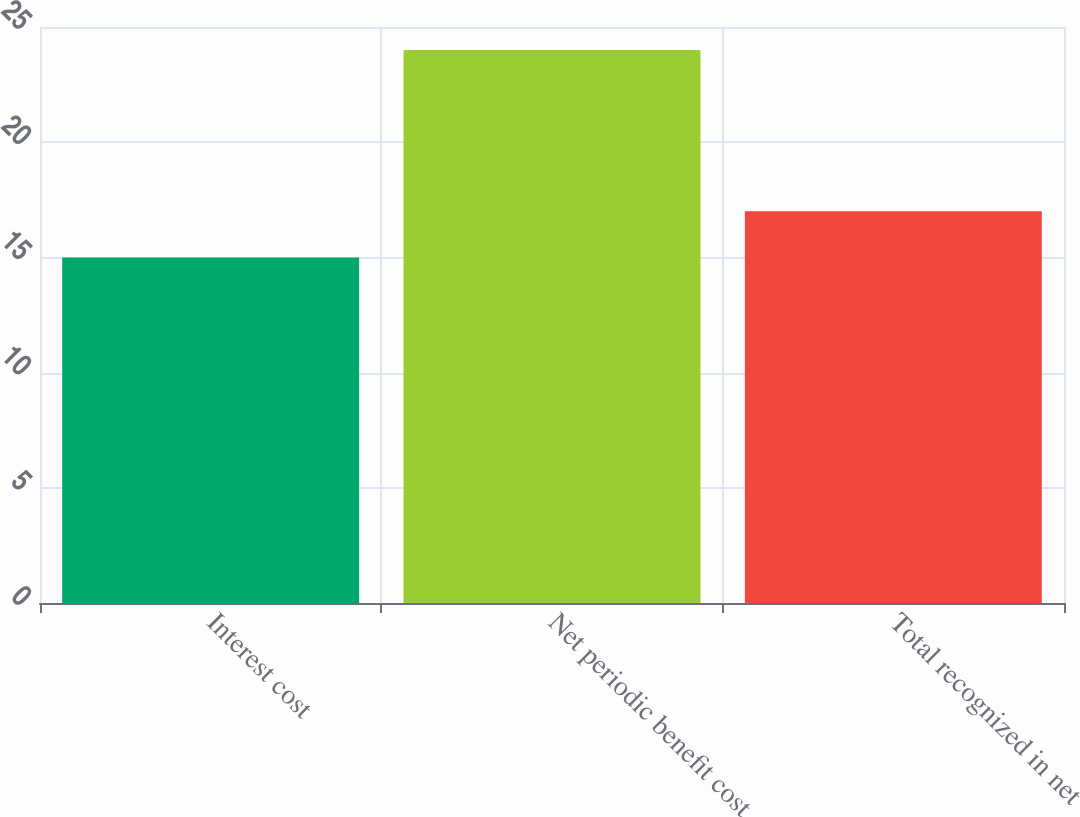Convert chart. <chart><loc_0><loc_0><loc_500><loc_500><bar_chart><fcel>Interest cost<fcel>Net periodic benefit cost<fcel>Total recognized in net<nl><fcel>15<fcel>24<fcel>17<nl></chart> 